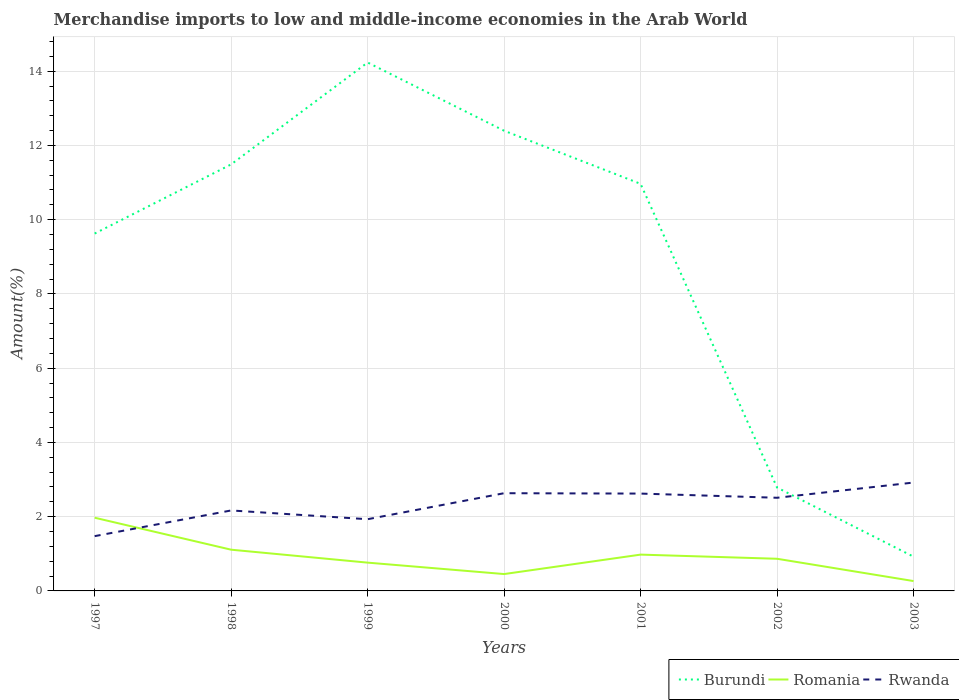Across all years, what is the maximum percentage of amount earned from merchandise imports in Burundi?
Keep it short and to the point. 0.92. What is the total percentage of amount earned from merchandise imports in Romania in the graph?
Your answer should be compact. 0.13. What is the difference between the highest and the second highest percentage of amount earned from merchandise imports in Rwanda?
Provide a succinct answer. 1.44. Is the percentage of amount earned from merchandise imports in Burundi strictly greater than the percentage of amount earned from merchandise imports in Romania over the years?
Provide a short and direct response. No. How many lines are there?
Provide a succinct answer. 3. How many years are there in the graph?
Provide a short and direct response. 7. What is the difference between two consecutive major ticks on the Y-axis?
Your answer should be compact. 2. Are the values on the major ticks of Y-axis written in scientific E-notation?
Keep it short and to the point. No. Does the graph contain any zero values?
Your answer should be very brief. No. How many legend labels are there?
Your answer should be very brief. 3. How are the legend labels stacked?
Give a very brief answer. Horizontal. What is the title of the graph?
Keep it short and to the point. Merchandise imports to low and middle-income economies in the Arab World. What is the label or title of the X-axis?
Ensure brevity in your answer.  Years. What is the label or title of the Y-axis?
Your answer should be very brief. Amount(%). What is the Amount(%) of Burundi in 1997?
Offer a very short reply. 9.63. What is the Amount(%) of Romania in 1997?
Give a very brief answer. 1.97. What is the Amount(%) in Rwanda in 1997?
Your response must be concise. 1.48. What is the Amount(%) of Burundi in 1998?
Make the answer very short. 11.49. What is the Amount(%) of Romania in 1998?
Keep it short and to the point. 1.11. What is the Amount(%) of Rwanda in 1998?
Give a very brief answer. 2.17. What is the Amount(%) of Burundi in 1999?
Offer a terse response. 14.23. What is the Amount(%) of Romania in 1999?
Ensure brevity in your answer.  0.76. What is the Amount(%) in Rwanda in 1999?
Keep it short and to the point. 1.93. What is the Amount(%) of Burundi in 2000?
Give a very brief answer. 12.4. What is the Amount(%) in Romania in 2000?
Your response must be concise. 0.45. What is the Amount(%) of Rwanda in 2000?
Make the answer very short. 2.63. What is the Amount(%) of Burundi in 2001?
Provide a succinct answer. 10.97. What is the Amount(%) in Romania in 2001?
Your answer should be very brief. 0.98. What is the Amount(%) in Rwanda in 2001?
Ensure brevity in your answer.  2.62. What is the Amount(%) in Burundi in 2002?
Provide a short and direct response. 2.78. What is the Amount(%) in Romania in 2002?
Keep it short and to the point. 0.87. What is the Amount(%) in Rwanda in 2002?
Give a very brief answer. 2.51. What is the Amount(%) of Burundi in 2003?
Your response must be concise. 0.92. What is the Amount(%) in Romania in 2003?
Offer a very short reply. 0.27. What is the Amount(%) in Rwanda in 2003?
Ensure brevity in your answer.  2.92. Across all years, what is the maximum Amount(%) of Burundi?
Ensure brevity in your answer.  14.23. Across all years, what is the maximum Amount(%) of Romania?
Your answer should be compact. 1.97. Across all years, what is the maximum Amount(%) in Rwanda?
Ensure brevity in your answer.  2.92. Across all years, what is the minimum Amount(%) in Burundi?
Give a very brief answer. 0.92. Across all years, what is the minimum Amount(%) in Romania?
Ensure brevity in your answer.  0.27. Across all years, what is the minimum Amount(%) in Rwanda?
Give a very brief answer. 1.48. What is the total Amount(%) of Burundi in the graph?
Provide a succinct answer. 62.42. What is the total Amount(%) of Romania in the graph?
Your answer should be compact. 6.41. What is the total Amount(%) in Rwanda in the graph?
Ensure brevity in your answer.  16.26. What is the difference between the Amount(%) of Burundi in 1997 and that in 1998?
Provide a succinct answer. -1.86. What is the difference between the Amount(%) of Romania in 1997 and that in 1998?
Your response must be concise. 0.86. What is the difference between the Amount(%) of Rwanda in 1997 and that in 1998?
Offer a very short reply. -0.69. What is the difference between the Amount(%) of Burundi in 1997 and that in 1999?
Ensure brevity in your answer.  -4.61. What is the difference between the Amount(%) in Romania in 1997 and that in 1999?
Offer a terse response. 1.21. What is the difference between the Amount(%) in Rwanda in 1997 and that in 1999?
Ensure brevity in your answer.  -0.46. What is the difference between the Amount(%) in Burundi in 1997 and that in 2000?
Ensure brevity in your answer.  -2.77. What is the difference between the Amount(%) of Romania in 1997 and that in 2000?
Ensure brevity in your answer.  1.52. What is the difference between the Amount(%) in Rwanda in 1997 and that in 2000?
Your response must be concise. -1.16. What is the difference between the Amount(%) of Burundi in 1997 and that in 2001?
Ensure brevity in your answer.  -1.34. What is the difference between the Amount(%) in Rwanda in 1997 and that in 2001?
Your answer should be very brief. -1.15. What is the difference between the Amount(%) in Burundi in 1997 and that in 2002?
Your response must be concise. 6.84. What is the difference between the Amount(%) of Romania in 1997 and that in 2002?
Provide a succinct answer. 1.11. What is the difference between the Amount(%) in Rwanda in 1997 and that in 2002?
Give a very brief answer. -1.03. What is the difference between the Amount(%) in Burundi in 1997 and that in 2003?
Keep it short and to the point. 8.7. What is the difference between the Amount(%) in Romania in 1997 and that in 2003?
Make the answer very short. 1.71. What is the difference between the Amount(%) in Rwanda in 1997 and that in 2003?
Make the answer very short. -1.44. What is the difference between the Amount(%) in Burundi in 1998 and that in 1999?
Provide a succinct answer. -2.74. What is the difference between the Amount(%) of Romania in 1998 and that in 1999?
Make the answer very short. 0.35. What is the difference between the Amount(%) of Rwanda in 1998 and that in 1999?
Keep it short and to the point. 0.24. What is the difference between the Amount(%) in Burundi in 1998 and that in 2000?
Provide a succinct answer. -0.91. What is the difference between the Amount(%) in Romania in 1998 and that in 2000?
Offer a very short reply. 0.66. What is the difference between the Amount(%) of Rwanda in 1998 and that in 2000?
Your answer should be very brief. -0.46. What is the difference between the Amount(%) in Burundi in 1998 and that in 2001?
Offer a terse response. 0.52. What is the difference between the Amount(%) in Romania in 1998 and that in 2001?
Your response must be concise. 0.13. What is the difference between the Amount(%) of Rwanda in 1998 and that in 2001?
Keep it short and to the point. -0.45. What is the difference between the Amount(%) in Burundi in 1998 and that in 2002?
Provide a succinct answer. 8.71. What is the difference between the Amount(%) of Romania in 1998 and that in 2002?
Provide a short and direct response. 0.24. What is the difference between the Amount(%) in Rwanda in 1998 and that in 2002?
Ensure brevity in your answer.  -0.34. What is the difference between the Amount(%) in Burundi in 1998 and that in 2003?
Your answer should be compact. 10.57. What is the difference between the Amount(%) of Romania in 1998 and that in 2003?
Make the answer very short. 0.85. What is the difference between the Amount(%) of Rwanda in 1998 and that in 2003?
Offer a very short reply. -0.75. What is the difference between the Amount(%) in Burundi in 1999 and that in 2000?
Offer a very short reply. 1.84. What is the difference between the Amount(%) of Romania in 1999 and that in 2000?
Offer a terse response. 0.31. What is the difference between the Amount(%) in Rwanda in 1999 and that in 2000?
Give a very brief answer. -0.7. What is the difference between the Amount(%) of Burundi in 1999 and that in 2001?
Give a very brief answer. 3.27. What is the difference between the Amount(%) in Romania in 1999 and that in 2001?
Offer a very short reply. -0.22. What is the difference between the Amount(%) of Rwanda in 1999 and that in 2001?
Your answer should be compact. -0.69. What is the difference between the Amount(%) in Burundi in 1999 and that in 2002?
Give a very brief answer. 11.45. What is the difference between the Amount(%) of Romania in 1999 and that in 2002?
Your response must be concise. -0.1. What is the difference between the Amount(%) of Rwanda in 1999 and that in 2002?
Offer a terse response. -0.58. What is the difference between the Amount(%) in Burundi in 1999 and that in 2003?
Give a very brief answer. 13.31. What is the difference between the Amount(%) of Romania in 1999 and that in 2003?
Offer a terse response. 0.5. What is the difference between the Amount(%) in Rwanda in 1999 and that in 2003?
Your answer should be very brief. -0.99. What is the difference between the Amount(%) of Burundi in 2000 and that in 2001?
Make the answer very short. 1.43. What is the difference between the Amount(%) of Romania in 2000 and that in 2001?
Provide a succinct answer. -0.52. What is the difference between the Amount(%) of Rwanda in 2000 and that in 2001?
Give a very brief answer. 0.01. What is the difference between the Amount(%) in Burundi in 2000 and that in 2002?
Your answer should be very brief. 9.61. What is the difference between the Amount(%) of Romania in 2000 and that in 2002?
Offer a very short reply. -0.41. What is the difference between the Amount(%) of Rwanda in 2000 and that in 2002?
Provide a succinct answer. 0.12. What is the difference between the Amount(%) in Burundi in 2000 and that in 2003?
Provide a short and direct response. 11.47. What is the difference between the Amount(%) of Romania in 2000 and that in 2003?
Provide a short and direct response. 0.19. What is the difference between the Amount(%) in Rwanda in 2000 and that in 2003?
Make the answer very short. -0.29. What is the difference between the Amount(%) of Burundi in 2001 and that in 2002?
Offer a terse response. 8.18. What is the difference between the Amount(%) in Romania in 2001 and that in 2002?
Provide a short and direct response. 0.11. What is the difference between the Amount(%) of Rwanda in 2001 and that in 2002?
Keep it short and to the point. 0.11. What is the difference between the Amount(%) in Burundi in 2001 and that in 2003?
Keep it short and to the point. 10.04. What is the difference between the Amount(%) in Romania in 2001 and that in 2003?
Your answer should be compact. 0.71. What is the difference between the Amount(%) of Rwanda in 2001 and that in 2003?
Make the answer very short. -0.3. What is the difference between the Amount(%) of Burundi in 2002 and that in 2003?
Provide a short and direct response. 1.86. What is the difference between the Amount(%) in Romania in 2002 and that in 2003?
Ensure brevity in your answer.  0.6. What is the difference between the Amount(%) in Rwanda in 2002 and that in 2003?
Ensure brevity in your answer.  -0.41. What is the difference between the Amount(%) of Burundi in 1997 and the Amount(%) of Romania in 1998?
Make the answer very short. 8.52. What is the difference between the Amount(%) in Burundi in 1997 and the Amount(%) in Rwanda in 1998?
Give a very brief answer. 7.46. What is the difference between the Amount(%) in Romania in 1997 and the Amount(%) in Rwanda in 1998?
Offer a terse response. -0.2. What is the difference between the Amount(%) in Burundi in 1997 and the Amount(%) in Romania in 1999?
Offer a terse response. 8.86. What is the difference between the Amount(%) of Burundi in 1997 and the Amount(%) of Rwanda in 1999?
Your answer should be very brief. 7.69. What is the difference between the Amount(%) in Romania in 1997 and the Amount(%) in Rwanda in 1999?
Your answer should be very brief. 0.04. What is the difference between the Amount(%) in Burundi in 1997 and the Amount(%) in Romania in 2000?
Keep it short and to the point. 9.17. What is the difference between the Amount(%) of Burundi in 1997 and the Amount(%) of Rwanda in 2000?
Offer a terse response. 6.99. What is the difference between the Amount(%) of Romania in 1997 and the Amount(%) of Rwanda in 2000?
Offer a very short reply. -0.66. What is the difference between the Amount(%) of Burundi in 1997 and the Amount(%) of Romania in 2001?
Offer a very short reply. 8.65. What is the difference between the Amount(%) of Burundi in 1997 and the Amount(%) of Rwanda in 2001?
Make the answer very short. 7. What is the difference between the Amount(%) of Romania in 1997 and the Amount(%) of Rwanda in 2001?
Offer a terse response. -0.65. What is the difference between the Amount(%) in Burundi in 1997 and the Amount(%) in Romania in 2002?
Ensure brevity in your answer.  8.76. What is the difference between the Amount(%) of Burundi in 1997 and the Amount(%) of Rwanda in 2002?
Give a very brief answer. 7.12. What is the difference between the Amount(%) of Romania in 1997 and the Amount(%) of Rwanda in 2002?
Keep it short and to the point. -0.54. What is the difference between the Amount(%) of Burundi in 1997 and the Amount(%) of Romania in 2003?
Keep it short and to the point. 9.36. What is the difference between the Amount(%) of Burundi in 1997 and the Amount(%) of Rwanda in 2003?
Ensure brevity in your answer.  6.71. What is the difference between the Amount(%) of Romania in 1997 and the Amount(%) of Rwanda in 2003?
Provide a succinct answer. -0.95. What is the difference between the Amount(%) of Burundi in 1998 and the Amount(%) of Romania in 1999?
Ensure brevity in your answer.  10.73. What is the difference between the Amount(%) in Burundi in 1998 and the Amount(%) in Rwanda in 1999?
Your response must be concise. 9.56. What is the difference between the Amount(%) of Romania in 1998 and the Amount(%) of Rwanda in 1999?
Your response must be concise. -0.82. What is the difference between the Amount(%) of Burundi in 1998 and the Amount(%) of Romania in 2000?
Offer a very short reply. 11.04. What is the difference between the Amount(%) in Burundi in 1998 and the Amount(%) in Rwanda in 2000?
Offer a very short reply. 8.86. What is the difference between the Amount(%) in Romania in 1998 and the Amount(%) in Rwanda in 2000?
Give a very brief answer. -1.52. What is the difference between the Amount(%) of Burundi in 1998 and the Amount(%) of Romania in 2001?
Provide a short and direct response. 10.51. What is the difference between the Amount(%) in Burundi in 1998 and the Amount(%) in Rwanda in 2001?
Keep it short and to the point. 8.87. What is the difference between the Amount(%) of Romania in 1998 and the Amount(%) of Rwanda in 2001?
Give a very brief answer. -1.51. What is the difference between the Amount(%) of Burundi in 1998 and the Amount(%) of Romania in 2002?
Offer a terse response. 10.62. What is the difference between the Amount(%) in Burundi in 1998 and the Amount(%) in Rwanda in 2002?
Make the answer very short. 8.98. What is the difference between the Amount(%) of Romania in 1998 and the Amount(%) of Rwanda in 2002?
Provide a short and direct response. -1.4. What is the difference between the Amount(%) of Burundi in 1998 and the Amount(%) of Romania in 2003?
Provide a succinct answer. 11.22. What is the difference between the Amount(%) of Burundi in 1998 and the Amount(%) of Rwanda in 2003?
Provide a succinct answer. 8.57. What is the difference between the Amount(%) of Romania in 1998 and the Amount(%) of Rwanda in 2003?
Make the answer very short. -1.81. What is the difference between the Amount(%) of Burundi in 1999 and the Amount(%) of Romania in 2000?
Give a very brief answer. 13.78. What is the difference between the Amount(%) in Burundi in 1999 and the Amount(%) in Rwanda in 2000?
Your response must be concise. 11.6. What is the difference between the Amount(%) in Romania in 1999 and the Amount(%) in Rwanda in 2000?
Offer a very short reply. -1.87. What is the difference between the Amount(%) in Burundi in 1999 and the Amount(%) in Romania in 2001?
Your answer should be compact. 13.26. What is the difference between the Amount(%) of Burundi in 1999 and the Amount(%) of Rwanda in 2001?
Your response must be concise. 11.61. What is the difference between the Amount(%) of Romania in 1999 and the Amount(%) of Rwanda in 2001?
Provide a short and direct response. -1.86. What is the difference between the Amount(%) of Burundi in 1999 and the Amount(%) of Romania in 2002?
Ensure brevity in your answer.  13.37. What is the difference between the Amount(%) of Burundi in 1999 and the Amount(%) of Rwanda in 2002?
Keep it short and to the point. 11.72. What is the difference between the Amount(%) in Romania in 1999 and the Amount(%) in Rwanda in 2002?
Your answer should be very brief. -1.75. What is the difference between the Amount(%) of Burundi in 1999 and the Amount(%) of Romania in 2003?
Offer a terse response. 13.97. What is the difference between the Amount(%) of Burundi in 1999 and the Amount(%) of Rwanda in 2003?
Your answer should be very brief. 11.31. What is the difference between the Amount(%) of Romania in 1999 and the Amount(%) of Rwanda in 2003?
Offer a very short reply. -2.16. What is the difference between the Amount(%) in Burundi in 2000 and the Amount(%) in Romania in 2001?
Make the answer very short. 11.42. What is the difference between the Amount(%) in Burundi in 2000 and the Amount(%) in Rwanda in 2001?
Provide a succinct answer. 9.77. What is the difference between the Amount(%) in Romania in 2000 and the Amount(%) in Rwanda in 2001?
Provide a short and direct response. -2.17. What is the difference between the Amount(%) in Burundi in 2000 and the Amount(%) in Romania in 2002?
Your answer should be compact. 11.53. What is the difference between the Amount(%) in Burundi in 2000 and the Amount(%) in Rwanda in 2002?
Your answer should be very brief. 9.89. What is the difference between the Amount(%) of Romania in 2000 and the Amount(%) of Rwanda in 2002?
Provide a short and direct response. -2.06. What is the difference between the Amount(%) of Burundi in 2000 and the Amount(%) of Romania in 2003?
Your answer should be compact. 12.13. What is the difference between the Amount(%) in Burundi in 2000 and the Amount(%) in Rwanda in 2003?
Offer a very short reply. 9.48. What is the difference between the Amount(%) in Romania in 2000 and the Amount(%) in Rwanda in 2003?
Keep it short and to the point. -2.47. What is the difference between the Amount(%) of Burundi in 2001 and the Amount(%) of Romania in 2002?
Offer a terse response. 10.1. What is the difference between the Amount(%) in Burundi in 2001 and the Amount(%) in Rwanda in 2002?
Offer a terse response. 8.46. What is the difference between the Amount(%) of Romania in 2001 and the Amount(%) of Rwanda in 2002?
Offer a terse response. -1.53. What is the difference between the Amount(%) of Burundi in 2001 and the Amount(%) of Romania in 2003?
Offer a terse response. 10.7. What is the difference between the Amount(%) of Burundi in 2001 and the Amount(%) of Rwanda in 2003?
Provide a succinct answer. 8.05. What is the difference between the Amount(%) in Romania in 2001 and the Amount(%) in Rwanda in 2003?
Your response must be concise. -1.94. What is the difference between the Amount(%) in Burundi in 2002 and the Amount(%) in Romania in 2003?
Your answer should be compact. 2.52. What is the difference between the Amount(%) of Burundi in 2002 and the Amount(%) of Rwanda in 2003?
Offer a very short reply. -0.14. What is the difference between the Amount(%) in Romania in 2002 and the Amount(%) in Rwanda in 2003?
Your answer should be very brief. -2.05. What is the average Amount(%) in Burundi per year?
Ensure brevity in your answer.  8.92. What is the average Amount(%) of Romania per year?
Your answer should be very brief. 0.92. What is the average Amount(%) in Rwanda per year?
Make the answer very short. 2.32. In the year 1997, what is the difference between the Amount(%) in Burundi and Amount(%) in Romania?
Your answer should be compact. 7.65. In the year 1997, what is the difference between the Amount(%) of Burundi and Amount(%) of Rwanda?
Make the answer very short. 8.15. In the year 1997, what is the difference between the Amount(%) in Romania and Amount(%) in Rwanda?
Offer a terse response. 0.5. In the year 1998, what is the difference between the Amount(%) of Burundi and Amount(%) of Romania?
Offer a terse response. 10.38. In the year 1998, what is the difference between the Amount(%) in Burundi and Amount(%) in Rwanda?
Provide a short and direct response. 9.32. In the year 1998, what is the difference between the Amount(%) in Romania and Amount(%) in Rwanda?
Ensure brevity in your answer.  -1.06. In the year 1999, what is the difference between the Amount(%) in Burundi and Amount(%) in Romania?
Offer a terse response. 13.47. In the year 1999, what is the difference between the Amount(%) in Burundi and Amount(%) in Rwanda?
Offer a very short reply. 12.3. In the year 1999, what is the difference between the Amount(%) of Romania and Amount(%) of Rwanda?
Give a very brief answer. -1.17. In the year 2000, what is the difference between the Amount(%) in Burundi and Amount(%) in Romania?
Make the answer very short. 11.94. In the year 2000, what is the difference between the Amount(%) of Burundi and Amount(%) of Rwanda?
Make the answer very short. 9.76. In the year 2000, what is the difference between the Amount(%) of Romania and Amount(%) of Rwanda?
Offer a very short reply. -2.18. In the year 2001, what is the difference between the Amount(%) in Burundi and Amount(%) in Romania?
Your response must be concise. 9.99. In the year 2001, what is the difference between the Amount(%) in Burundi and Amount(%) in Rwanda?
Make the answer very short. 8.34. In the year 2001, what is the difference between the Amount(%) in Romania and Amount(%) in Rwanda?
Offer a terse response. -1.64. In the year 2002, what is the difference between the Amount(%) of Burundi and Amount(%) of Romania?
Provide a succinct answer. 1.92. In the year 2002, what is the difference between the Amount(%) of Burundi and Amount(%) of Rwanda?
Your answer should be very brief. 0.28. In the year 2002, what is the difference between the Amount(%) in Romania and Amount(%) in Rwanda?
Your answer should be compact. -1.64. In the year 2003, what is the difference between the Amount(%) of Burundi and Amount(%) of Romania?
Offer a terse response. 0.66. In the year 2003, what is the difference between the Amount(%) in Burundi and Amount(%) in Rwanda?
Give a very brief answer. -2. In the year 2003, what is the difference between the Amount(%) in Romania and Amount(%) in Rwanda?
Make the answer very short. -2.65. What is the ratio of the Amount(%) in Burundi in 1997 to that in 1998?
Provide a short and direct response. 0.84. What is the ratio of the Amount(%) of Romania in 1997 to that in 1998?
Your answer should be compact. 1.78. What is the ratio of the Amount(%) in Rwanda in 1997 to that in 1998?
Your answer should be compact. 0.68. What is the ratio of the Amount(%) in Burundi in 1997 to that in 1999?
Your answer should be very brief. 0.68. What is the ratio of the Amount(%) in Romania in 1997 to that in 1999?
Your answer should be very brief. 2.59. What is the ratio of the Amount(%) of Rwanda in 1997 to that in 1999?
Your answer should be compact. 0.76. What is the ratio of the Amount(%) in Burundi in 1997 to that in 2000?
Provide a short and direct response. 0.78. What is the ratio of the Amount(%) of Romania in 1997 to that in 2000?
Make the answer very short. 4.34. What is the ratio of the Amount(%) of Rwanda in 1997 to that in 2000?
Your response must be concise. 0.56. What is the ratio of the Amount(%) in Burundi in 1997 to that in 2001?
Provide a succinct answer. 0.88. What is the ratio of the Amount(%) of Romania in 1997 to that in 2001?
Make the answer very short. 2.02. What is the ratio of the Amount(%) in Rwanda in 1997 to that in 2001?
Offer a terse response. 0.56. What is the ratio of the Amount(%) in Burundi in 1997 to that in 2002?
Offer a very short reply. 3.46. What is the ratio of the Amount(%) of Romania in 1997 to that in 2002?
Your answer should be very brief. 2.28. What is the ratio of the Amount(%) in Rwanda in 1997 to that in 2002?
Your answer should be very brief. 0.59. What is the ratio of the Amount(%) in Burundi in 1997 to that in 2003?
Offer a terse response. 10.44. What is the ratio of the Amount(%) of Romania in 1997 to that in 2003?
Your response must be concise. 7.43. What is the ratio of the Amount(%) of Rwanda in 1997 to that in 2003?
Make the answer very short. 0.51. What is the ratio of the Amount(%) in Burundi in 1998 to that in 1999?
Provide a short and direct response. 0.81. What is the ratio of the Amount(%) in Romania in 1998 to that in 1999?
Provide a short and direct response. 1.46. What is the ratio of the Amount(%) of Rwanda in 1998 to that in 1999?
Your answer should be compact. 1.12. What is the ratio of the Amount(%) of Burundi in 1998 to that in 2000?
Give a very brief answer. 0.93. What is the ratio of the Amount(%) of Romania in 1998 to that in 2000?
Give a very brief answer. 2.44. What is the ratio of the Amount(%) in Rwanda in 1998 to that in 2000?
Offer a very short reply. 0.82. What is the ratio of the Amount(%) in Burundi in 1998 to that in 2001?
Provide a short and direct response. 1.05. What is the ratio of the Amount(%) of Romania in 1998 to that in 2001?
Offer a very short reply. 1.14. What is the ratio of the Amount(%) of Rwanda in 1998 to that in 2001?
Make the answer very short. 0.83. What is the ratio of the Amount(%) of Burundi in 1998 to that in 2002?
Offer a very short reply. 4.13. What is the ratio of the Amount(%) in Romania in 1998 to that in 2002?
Give a very brief answer. 1.28. What is the ratio of the Amount(%) in Rwanda in 1998 to that in 2002?
Your answer should be compact. 0.86. What is the ratio of the Amount(%) of Burundi in 1998 to that in 2003?
Provide a short and direct response. 12.46. What is the ratio of the Amount(%) of Romania in 1998 to that in 2003?
Your response must be concise. 4.18. What is the ratio of the Amount(%) of Rwanda in 1998 to that in 2003?
Provide a short and direct response. 0.74. What is the ratio of the Amount(%) in Burundi in 1999 to that in 2000?
Your answer should be very brief. 1.15. What is the ratio of the Amount(%) in Romania in 1999 to that in 2000?
Give a very brief answer. 1.68. What is the ratio of the Amount(%) in Rwanda in 1999 to that in 2000?
Provide a succinct answer. 0.73. What is the ratio of the Amount(%) in Burundi in 1999 to that in 2001?
Offer a very short reply. 1.3. What is the ratio of the Amount(%) in Romania in 1999 to that in 2001?
Your answer should be very brief. 0.78. What is the ratio of the Amount(%) of Rwanda in 1999 to that in 2001?
Your answer should be compact. 0.74. What is the ratio of the Amount(%) of Burundi in 1999 to that in 2002?
Keep it short and to the point. 5.11. What is the ratio of the Amount(%) of Romania in 1999 to that in 2002?
Your response must be concise. 0.88. What is the ratio of the Amount(%) in Rwanda in 1999 to that in 2002?
Provide a short and direct response. 0.77. What is the ratio of the Amount(%) of Burundi in 1999 to that in 2003?
Provide a succinct answer. 15.44. What is the ratio of the Amount(%) in Romania in 1999 to that in 2003?
Ensure brevity in your answer.  2.87. What is the ratio of the Amount(%) of Rwanda in 1999 to that in 2003?
Make the answer very short. 0.66. What is the ratio of the Amount(%) in Burundi in 2000 to that in 2001?
Ensure brevity in your answer.  1.13. What is the ratio of the Amount(%) of Romania in 2000 to that in 2001?
Give a very brief answer. 0.46. What is the ratio of the Amount(%) of Burundi in 2000 to that in 2002?
Provide a succinct answer. 4.45. What is the ratio of the Amount(%) of Romania in 2000 to that in 2002?
Your answer should be compact. 0.52. What is the ratio of the Amount(%) of Rwanda in 2000 to that in 2002?
Give a very brief answer. 1.05. What is the ratio of the Amount(%) of Burundi in 2000 to that in 2003?
Your answer should be very brief. 13.45. What is the ratio of the Amount(%) in Romania in 2000 to that in 2003?
Offer a terse response. 1.71. What is the ratio of the Amount(%) in Rwanda in 2000 to that in 2003?
Your answer should be compact. 0.9. What is the ratio of the Amount(%) of Burundi in 2001 to that in 2002?
Your answer should be very brief. 3.94. What is the ratio of the Amount(%) in Romania in 2001 to that in 2002?
Offer a very short reply. 1.13. What is the ratio of the Amount(%) in Rwanda in 2001 to that in 2002?
Your response must be concise. 1.04. What is the ratio of the Amount(%) in Burundi in 2001 to that in 2003?
Make the answer very short. 11.89. What is the ratio of the Amount(%) of Romania in 2001 to that in 2003?
Offer a terse response. 3.68. What is the ratio of the Amount(%) in Rwanda in 2001 to that in 2003?
Give a very brief answer. 0.9. What is the ratio of the Amount(%) in Burundi in 2002 to that in 2003?
Your answer should be compact. 3.02. What is the ratio of the Amount(%) of Romania in 2002 to that in 2003?
Provide a succinct answer. 3.26. What is the ratio of the Amount(%) in Rwanda in 2002 to that in 2003?
Ensure brevity in your answer.  0.86. What is the difference between the highest and the second highest Amount(%) of Burundi?
Your response must be concise. 1.84. What is the difference between the highest and the second highest Amount(%) of Romania?
Give a very brief answer. 0.86. What is the difference between the highest and the second highest Amount(%) of Rwanda?
Provide a short and direct response. 0.29. What is the difference between the highest and the lowest Amount(%) in Burundi?
Keep it short and to the point. 13.31. What is the difference between the highest and the lowest Amount(%) of Romania?
Make the answer very short. 1.71. What is the difference between the highest and the lowest Amount(%) in Rwanda?
Ensure brevity in your answer.  1.44. 